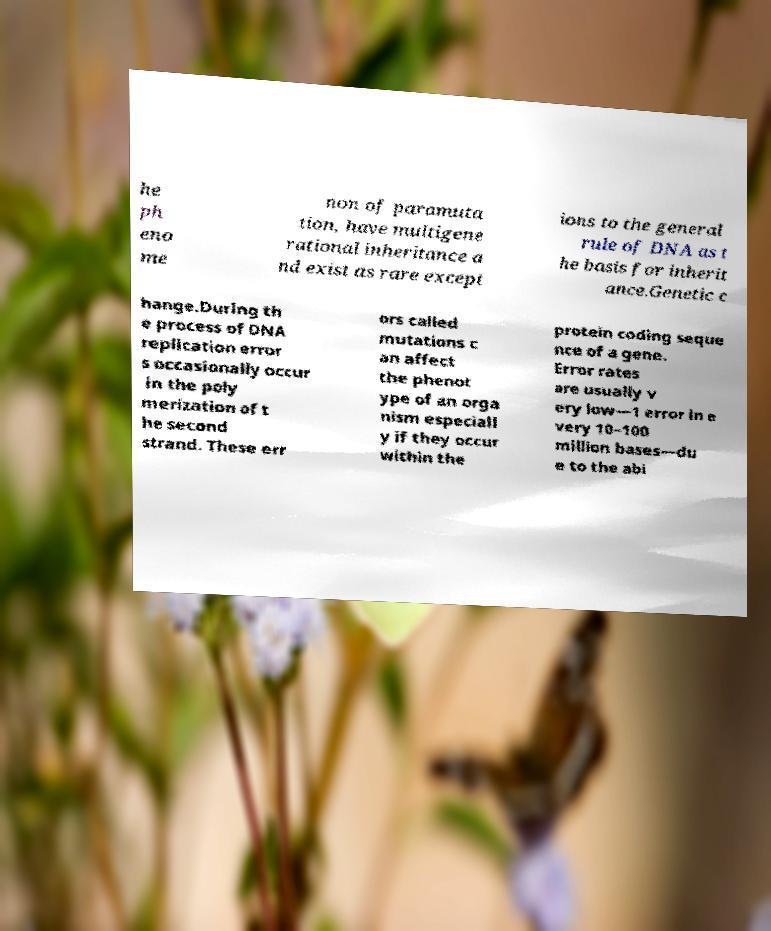I need the written content from this picture converted into text. Can you do that? he ph eno me non of paramuta tion, have multigene rational inheritance a nd exist as rare except ions to the general rule of DNA as t he basis for inherit ance.Genetic c hange.During th e process of DNA replication error s occasionally occur in the poly merization of t he second strand. These err ors called mutations c an affect the phenot ype of an orga nism especiall y if they occur within the protein coding seque nce of a gene. Error rates are usually v ery low—1 error in e very 10–100 million bases—du e to the abi 